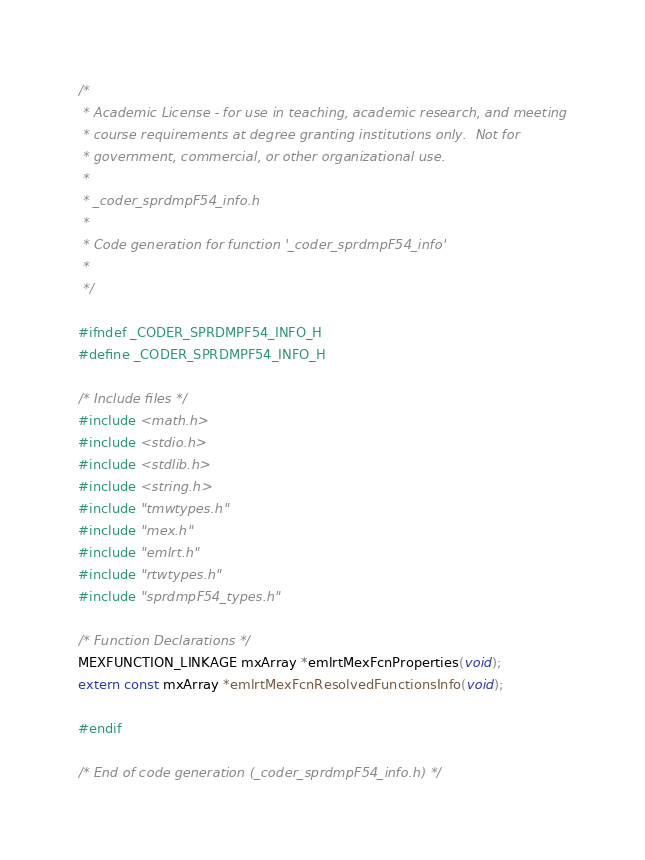<code> <loc_0><loc_0><loc_500><loc_500><_C_>/*
 * Academic License - for use in teaching, academic research, and meeting
 * course requirements at degree granting institutions only.  Not for
 * government, commercial, or other organizational use.
 *
 * _coder_sprdmpF54_info.h
 *
 * Code generation for function '_coder_sprdmpF54_info'
 *
 */

#ifndef _CODER_SPRDMPF54_INFO_H
#define _CODER_SPRDMPF54_INFO_H

/* Include files */
#include <math.h>
#include <stdio.h>
#include <stdlib.h>
#include <string.h>
#include "tmwtypes.h"
#include "mex.h"
#include "emlrt.h"
#include "rtwtypes.h"
#include "sprdmpF54_types.h"

/* Function Declarations */
MEXFUNCTION_LINKAGE mxArray *emlrtMexFcnProperties(void);
extern const mxArray *emlrtMexFcnResolvedFunctionsInfo(void);

#endif

/* End of code generation (_coder_sprdmpF54_info.h) */
</code> 